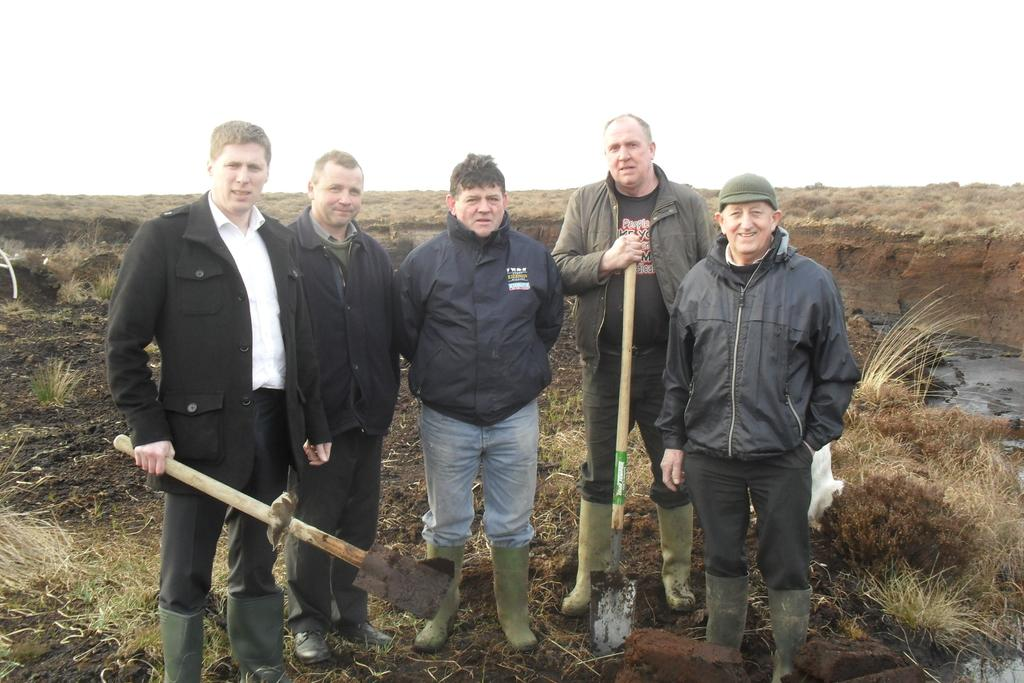What type of surface can be seen in the image? There is ground visible in the image. What type of vegetation is present in the image? There are plants and grass in the image. What are the men in the image doing? Some men are standing, and some are holding tools. What is the men's observation about the sky in the image? There is no mention of the sky or any observation about it in the image. 